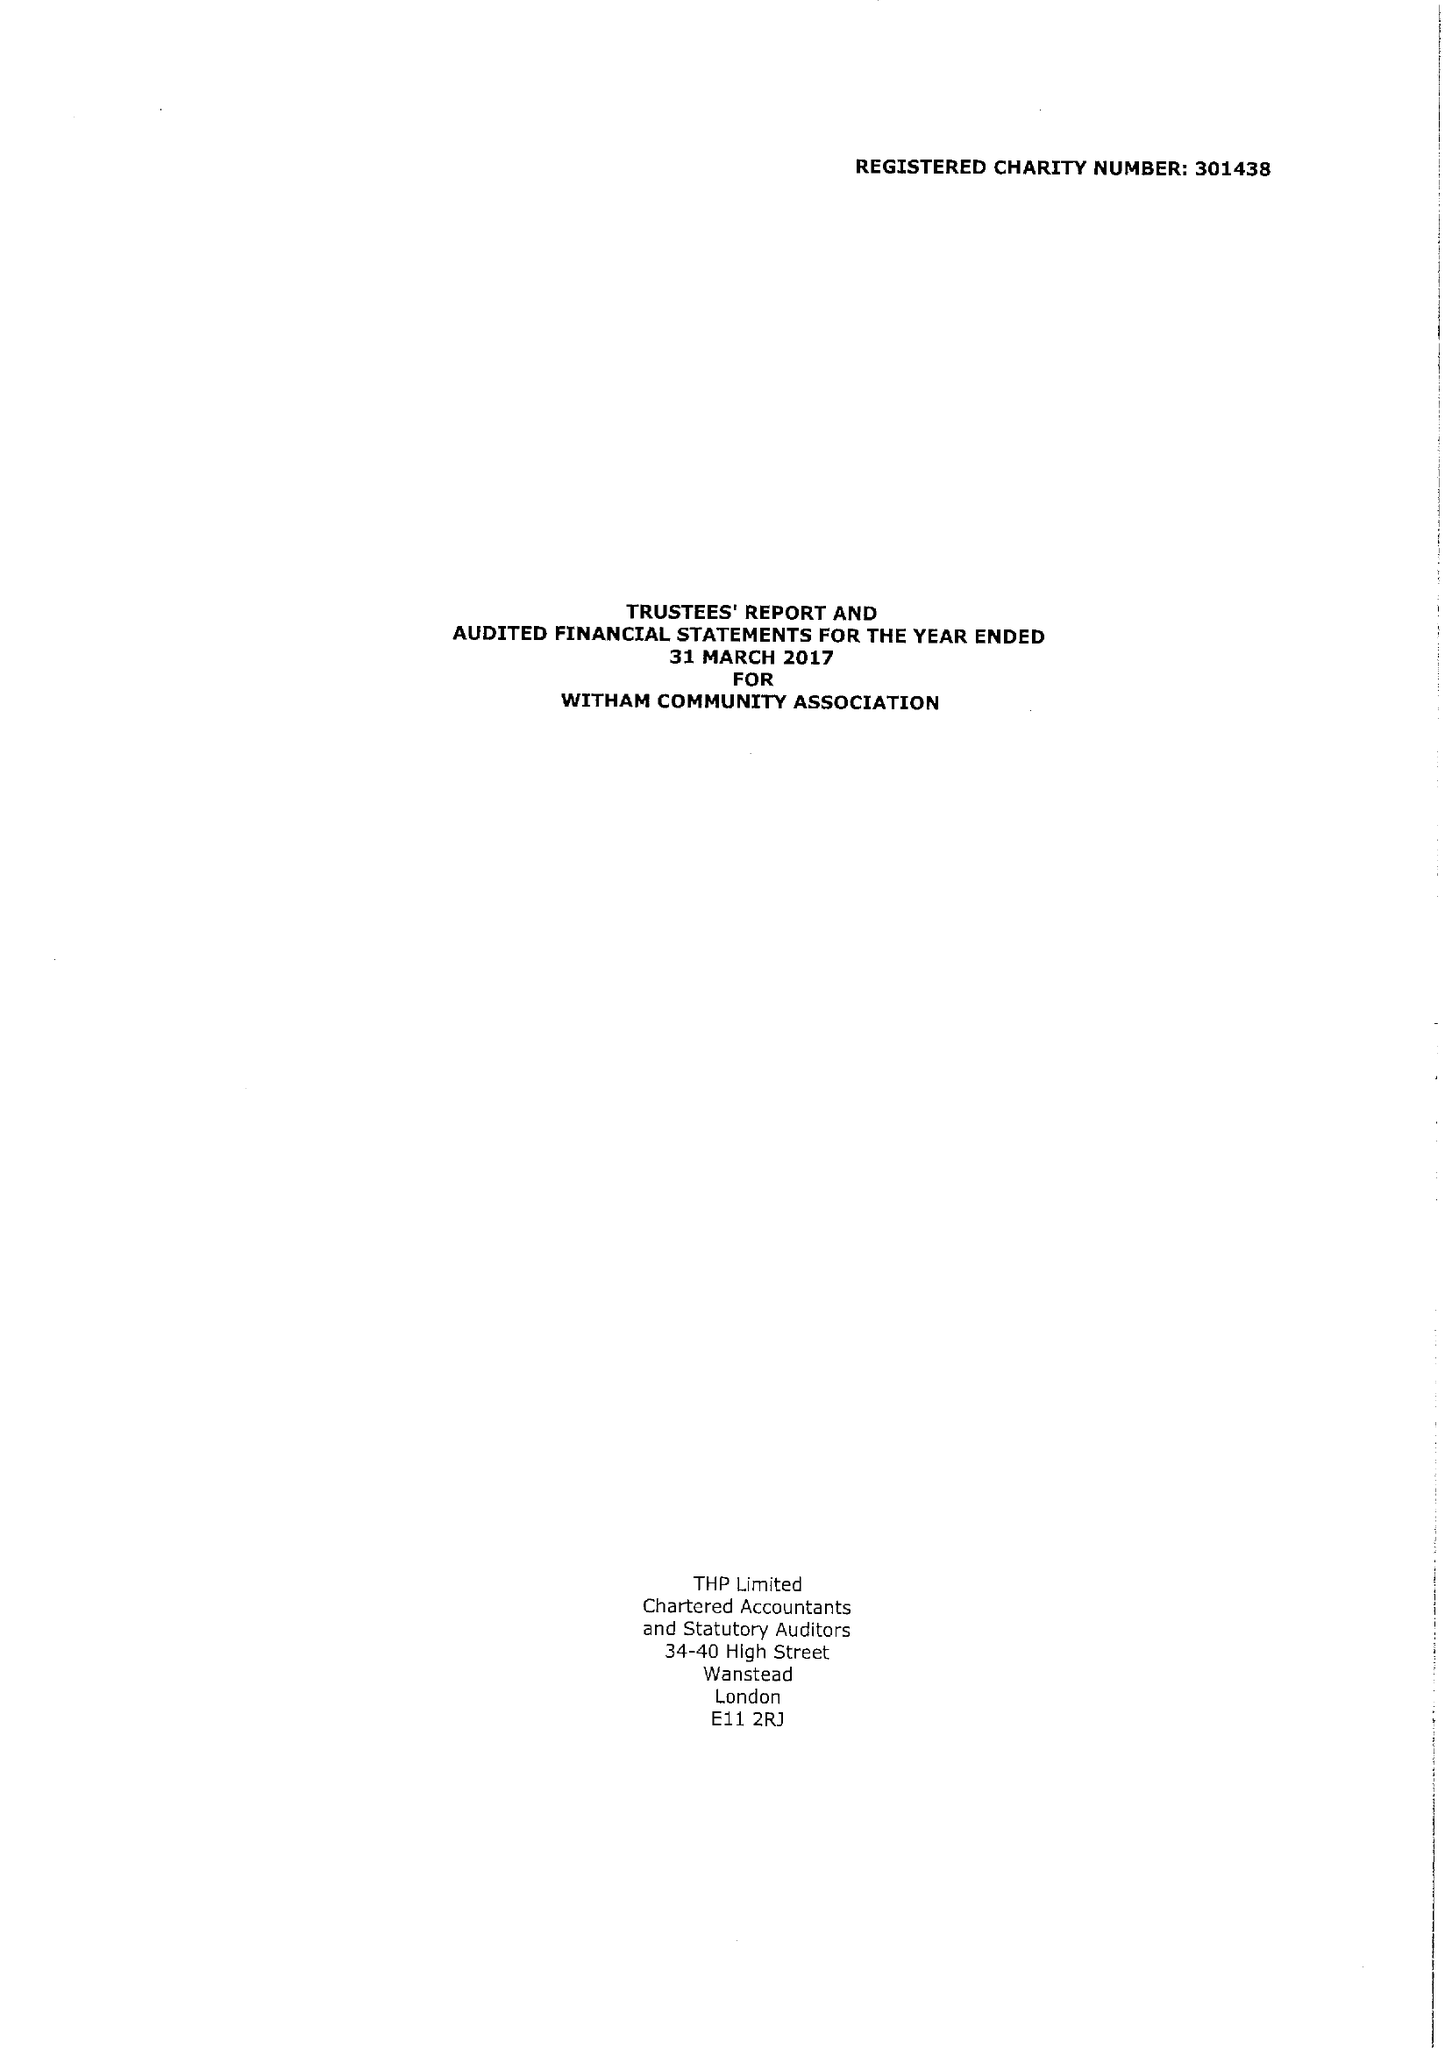What is the value for the address__street_line?
Answer the question using a single word or phrase. 7 STOURTON ROAD 